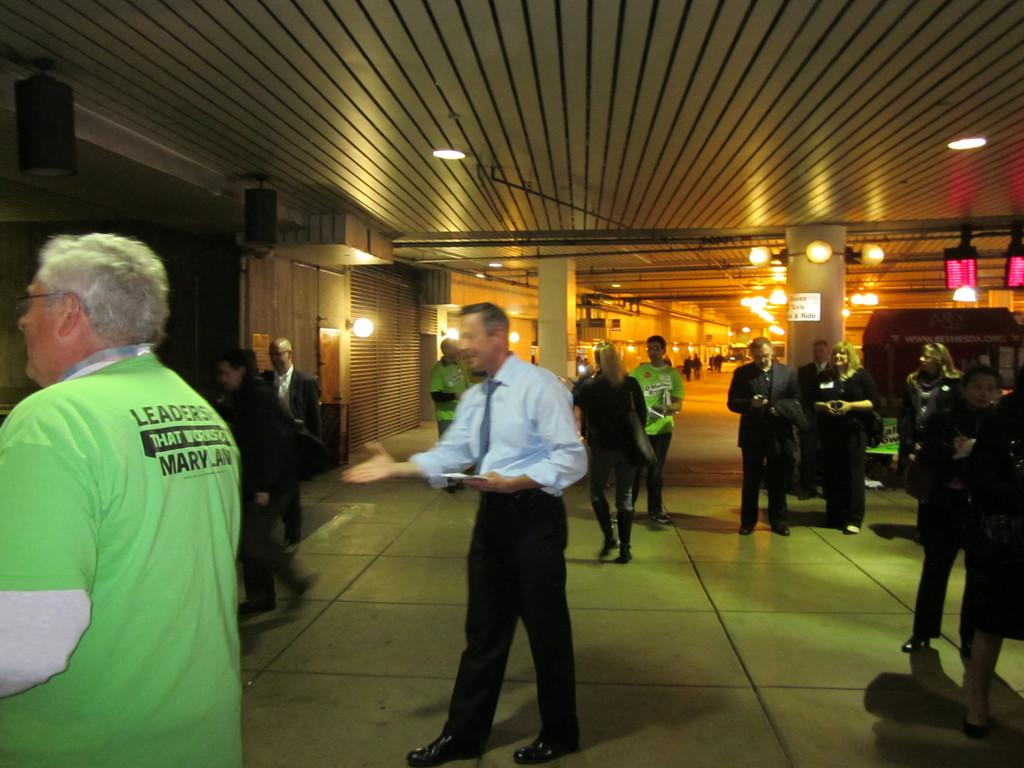What is the main subject of the image? The main subject of the image is a man walking in the middle of the image. What is the man wearing? The man is wearing a shirt, trousers, and a tie. Are there any other people in the image? Yes, there is another man on the left side of the image. What is the second man wearing? The second man is wearing a green color t-shirt. What is the man's opinion on the existence of rain in the image? The image does not provide any information about the man's opinion on the existence of rain, as it is not mentioned or depicted in the image. 